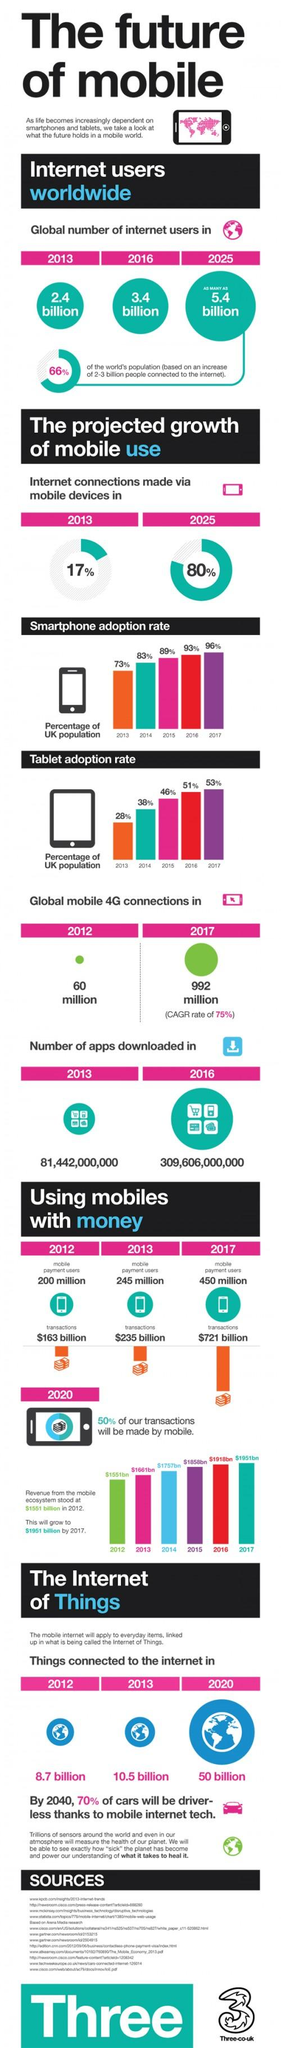Point out several critical features in this image. According to data from 2013 to 2017, the average adoption rate of tablets was 43.2%. During the period from 2012 to 2016, a total of 228,164,000,000 apps were downloaded. During the period of 2013 to 2017, the average smartphone adoption rate in the UK was 86.8%. In 2012, 2013, and 2017, a total value of 1,119 billion was transacted. From 2012 to 2017, the number of mobile connections increased by 932 million. 